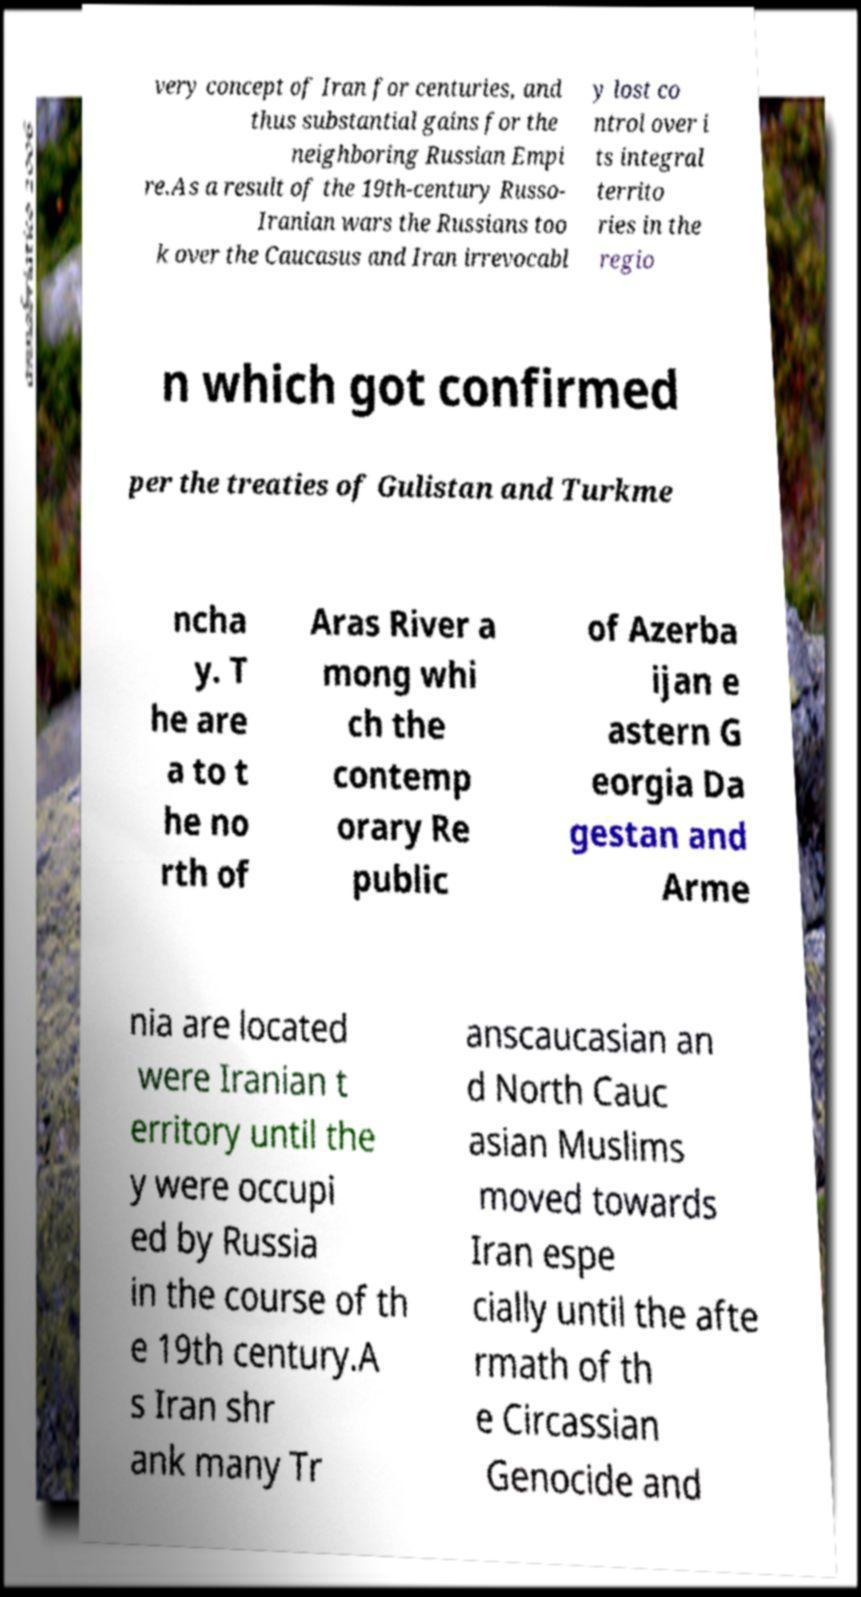Could you assist in decoding the text presented in this image and type it out clearly? very concept of Iran for centuries, and thus substantial gains for the neighboring Russian Empi re.As a result of the 19th-century Russo- Iranian wars the Russians too k over the Caucasus and Iran irrevocabl y lost co ntrol over i ts integral territo ries in the regio n which got confirmed per the treaties of Gulistan and Turkme ncha y. T he are a to t he no rth of Aras River a mong whi ch the contemp orary Re public of Azerba ijan e astern G eorgia Da gestan and Arme nia are located were Iranian t erritory until the y were occupi ed by Russia in the course of th e 19th century.A s Iran shr ank many Tr anscaucasian an d North Cauc asian Muslims moved towards Iran espe cially until the afte rmath of th e Circassian Genocide and 